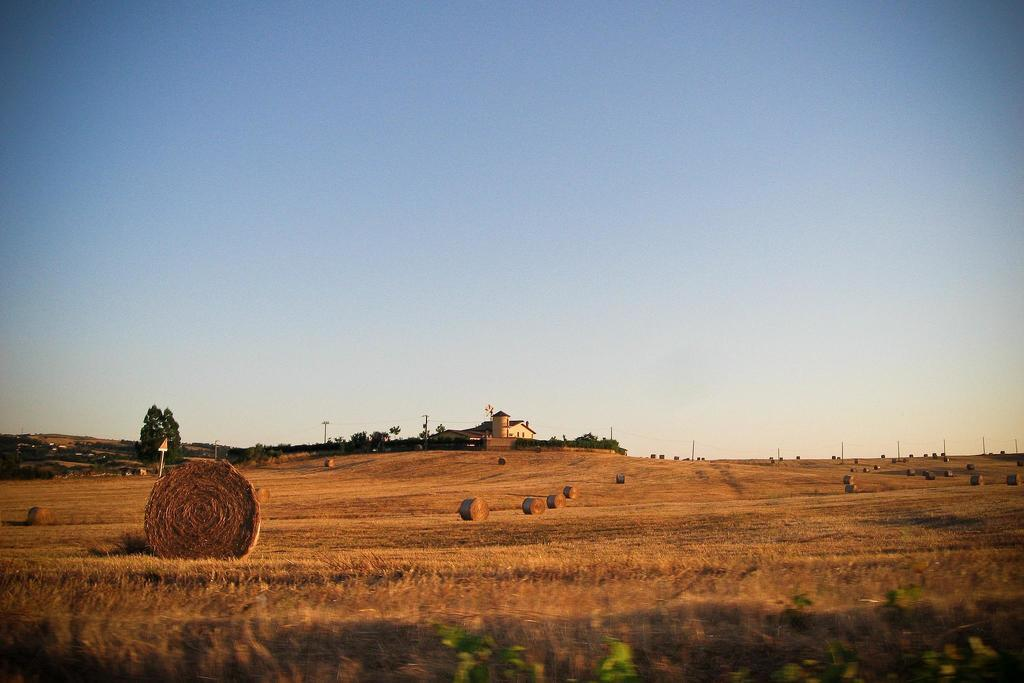What type of vegetation is present on the ground in the center of the image? There is grass on the ground in the center of the image. What can be seen in the background of the image? There are trees and a building in the background of the image. What is the color of the objects on the ground? The objects on the ground are brown in color. What type of company is providing assistance in the image? There is no company or assistance being provided in the image. 